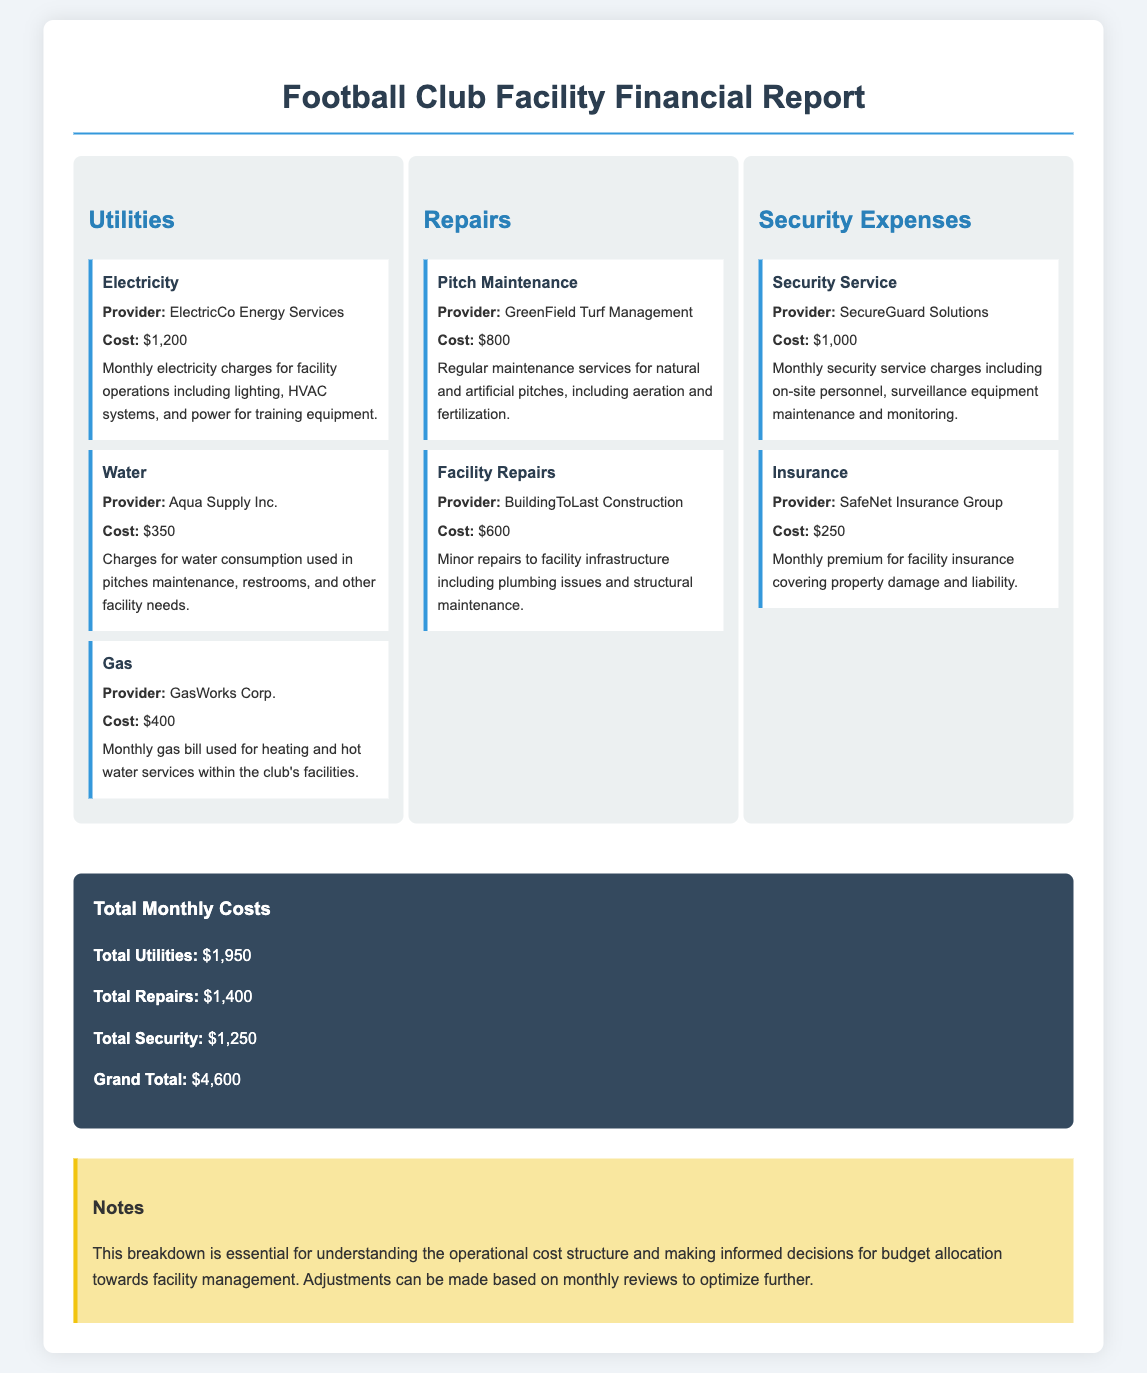What is the total cost of utilities? The total cost of utilities is provided in the document as the sum of all utility expenses listed, which is $1,200 + $350 + $400.
Answer: $1,950 Who is the provider of security service? The provider of the security service is specifically mentioned in the document as SecureGuard Solutions.
Answer: SecureGuard Solutions What is the cost for pitch maintenance? The cost for pitch maintenance is detailed in the document as $800 for the regular maintenance of the pitches.
Answer: $800 What is the grand total of all monthly costs? The grand total is computed by adding total utilities, repairs, and security expenses detailed in the document, resulting in $1,950 + $1,400 + $1,250.
Answer: $4,600 How much is the monthly premium for insurance? The document indicates the monthly premium for insurance, which is noted as $250.
Answer: $250 Which category has the highest total cost? The document lists the total costs for utilities, repairs, and security, where utilities total $1,950 is the highest.
Answer: Utilities What are the total repairs costs? The total repairs costs are provided as the sum of all repair expenses detailed in the document, which is $800 + $600.
Answer: $1,400 What type of document is this? The document is clearly labeled as a financial report focusing on monthly facility maintenance and operational costs.
Answer: Financial report 